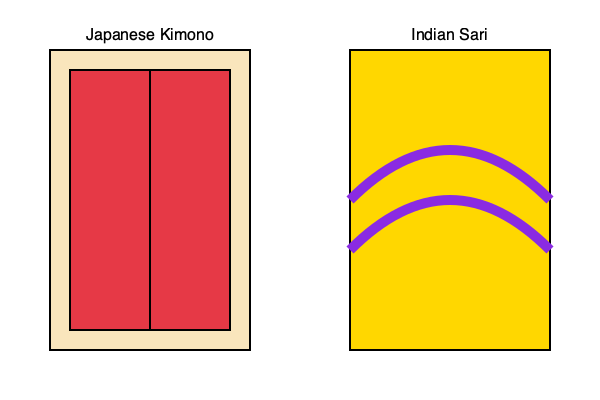Compare the traditional attire shown in the illustration. Which garment is typically wrapped around the body multiple times and can be draped in various styles? To answer this question, let's analyze the two traditional garments illustrated:

1. Japanese Kimono (left):
   - Consists of a long, straight-lined robe
   - Has wide sleeves
   - Wrapped around the body, but typically only once
   - Secured with a sash called an obi
   - Generally maintains a consistent shape when worn

2. Indian Sari (right):
   - Long piece of fabric, usually 5-9 meters in length
   - Shown with curved lines, indicating draping
   - Can be wrapped around the body multiple times
   - Allows for various draping styles depending on region and occasion
   - More versatile in its arrangement on the body

Based on these characteristics, the garment that is typically wrapped around the body multiple times and can be draped in various styles is the Indian Sari. The sari's length and flexibility allow for numerous draping methods, making it adaptable to different regional traditions and personal preferences.
Answer: Indian Sari 